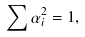<formula> <loc_0><loc_0><loc_500><loc_500>\sum \alpha _ { i } ^ { 2 } = 1 ,</formula> 